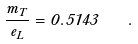Convert formula to latex. <formula><loc_0><loc_0><loc_500><loc_500>\frac { m _ { T } } { e _ { L } } = 0 . 5 1 4 3 \quad .</formula> 